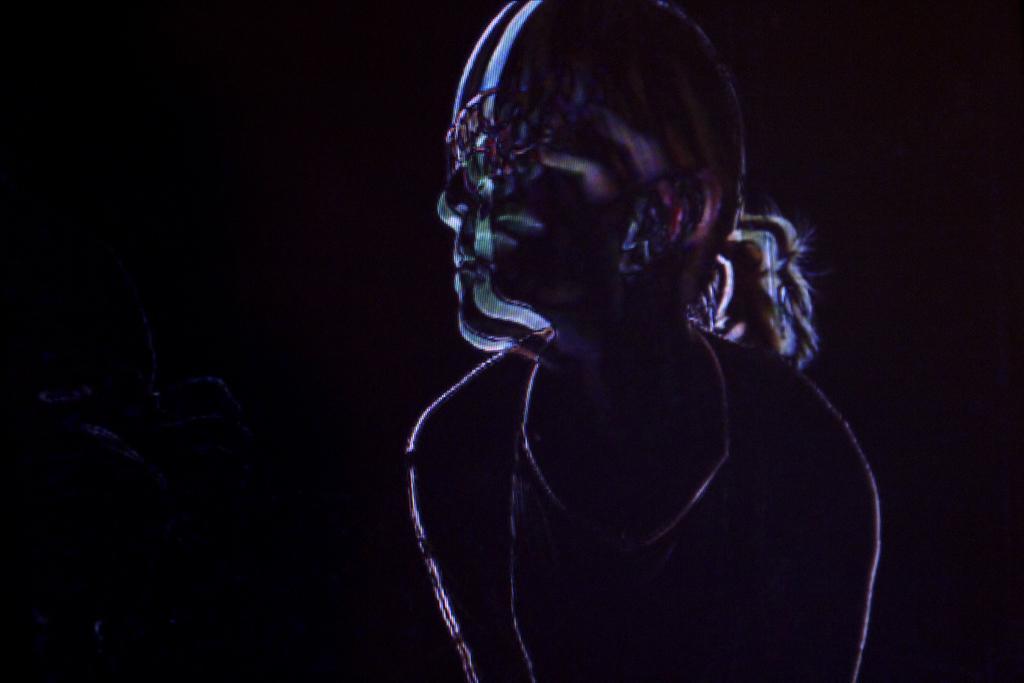In one or two sentences, can you explain what this image depicts? In this edited image there is a woman in the foreground and there is dark in the background. 